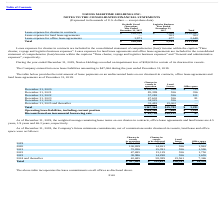According to Navios Maritime Holdings's financial document, What was the weighted average remaining lease terms on the company's land leases as of end 2019? According to the financial document, 46.3 years. The relevant text states: "years, 1.9 years and 46.3 years, respectively...." Also, What were the payments for office space in 2022? According to the financial document, 101 (in thousands). The relevant text states: "December 31, 2022 57,282 556 101..." Also, What were the payments for Charter-in vessels in operation in 2020? According to the financial document, 109,574 (in thousands). The relevant text states: "December 31, 2020 $109,574 $ 556 $ 753..." Additionally, Which lease payments had a total that exceeded $100,000 thousand? Charter-in vessels in operation. The document states: "Charter-in vessels in operation..." Also, can you calculate: What was the change in the payments for Charter-in vessels in operation between 2022 and 2023? Based on the calculation: 47,603-57,282, the result is -9679 (in thousands). This is based on the information: "December 31, 2022 57,282 556 101 December 31, 2023 47,603 556 81..." The key data points involved are: 47,603, 57,282. Also, can you calculate: What was the difference in the Discount based on incremental borrowing rate between Charter-in vessels in operation and Land Leases?  Based on the calculation: 62,796-18,122, the result is 44674 (in thousands). This is based on the information: "Discount based on incremental borrowing rate $ 62,796 $18,122 $ 87 unt based on incremental borrowing rate $ 62,796 $18,122 $ 87..." The key data points involved are: 18,122, 62,796. 